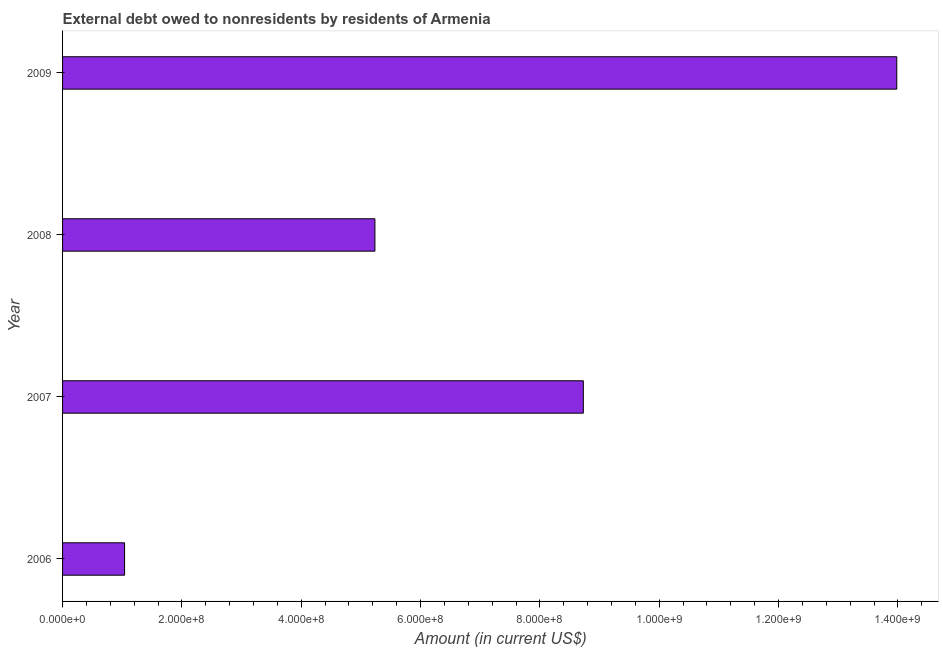Does the graph contain any zero values?
Ensure brevity in your answer.  No. What is the title of the graph?
Your answer should be very brief. External debt owed to nonresidents by residents of Armenia. What is the label or title of the X-axis?
Provide a succinct answer. Amount (in current US$). What is the debt in 2008?
Give a very brief answer. 5.24e+08. Across all years, what is the maximum debt?
Offer a very short reply. 1.40e+09. Across all years, what is the minimum debt?
Offer a very short reply. 1.04e+08. In which year was the debt minimum?
Offer a terse response. 2006. What is the sum of the debt?
Provide a short and direct response. 2.90e+09. What is the difference between the debt in 2006 and 2009?
Offer a terse response. -1.29e+09. What is the average debt per year?
Provide a short and direct response. 7.25e+08. What is the median debt?
Your response must be concise. 6.98e+08. What is the ratio of the debt in 2006 to that in 2007?
Give a very brief answer. 0.12. Is the difference between the debt in 2007 and 2008 greater than the difference between any two years?
Make the answer very short. No. What is the difference between the highest and the second highest debt?
Your answer should be very brief. 5.25e+08. Is the sum of the debt in 2007 and 2009 greater than the maximum debt across all years?
Provide a short and direct response. Yes. What is the difference between the highest and the lowest debt?
Provide a short and direct response. 1.29e+09. Are all the bars in the graph horizontal?
Provide a short and direct response. Yes. How many years are there in the graph?
Your answer should be compact. 4. Are the values on the major ticks of X-axis written in scientific E-notation?
Give a very brief answer. Yes. What is the Amount (in current US$) of 2006?
Offer a very short reply. 1.04e+08. What is the Amount (in current US$) in 2007?
Ensure brevity in your answer.  8.73e+08. What is the Amount (in current US$) in 2008?
Your answer should be compact. 5.24e+08. What is the Amount (in current US$) in 2009?
Give a very brief answer. 1.40e+09. What is the difference between the Amount (in current US$) in 2006 and 2007?
Offer a terse response. -7.69e+08. What is the difference between the Amount (in current US$) in 2006 and 2008?
Your response must be concise. -4.20e+08. What is the difference between the Amount (in current US$) in 2006 and 2009?
Offer a terse response. -1.29e+09. What is the difference between the Amount (in current US$) in 2007 and 2008?
Offer a terse response. 3.49e+08. What is the difference between the Amount (in current US$) in 2007 and 2009?
Your answer should be very brief. -5.25e+08. What is the difference between the Amount (in current US$) in 2008 and 2009?
Ensure brevity in your answer.  -8.75e+08. What is the ratio of the Amount (in current US$) in 2006 to that in 2007?
Your response must be concise. 0.12. What is the ratio of the Amount (in current US$) in 2006 to that in 2008?
Your response must be concise. 0.2. What is the ratio of the Amount (in current US$) in 2006 to that in 2009?
Provide a short and direct response. 0.07. What is the ratio of the Amount (in current US$) in 2007 to that in 2008?
Provide a short and direct response. 1.67. What is the ratio of the Amount (in current US$) in 2007 to that in 2009?
Ensure brevity in your answer.  0.62. What is the ratio of the Amount (in current US$) in 2008 to that in 2009?
Keep it short and to the point. 0.37. 